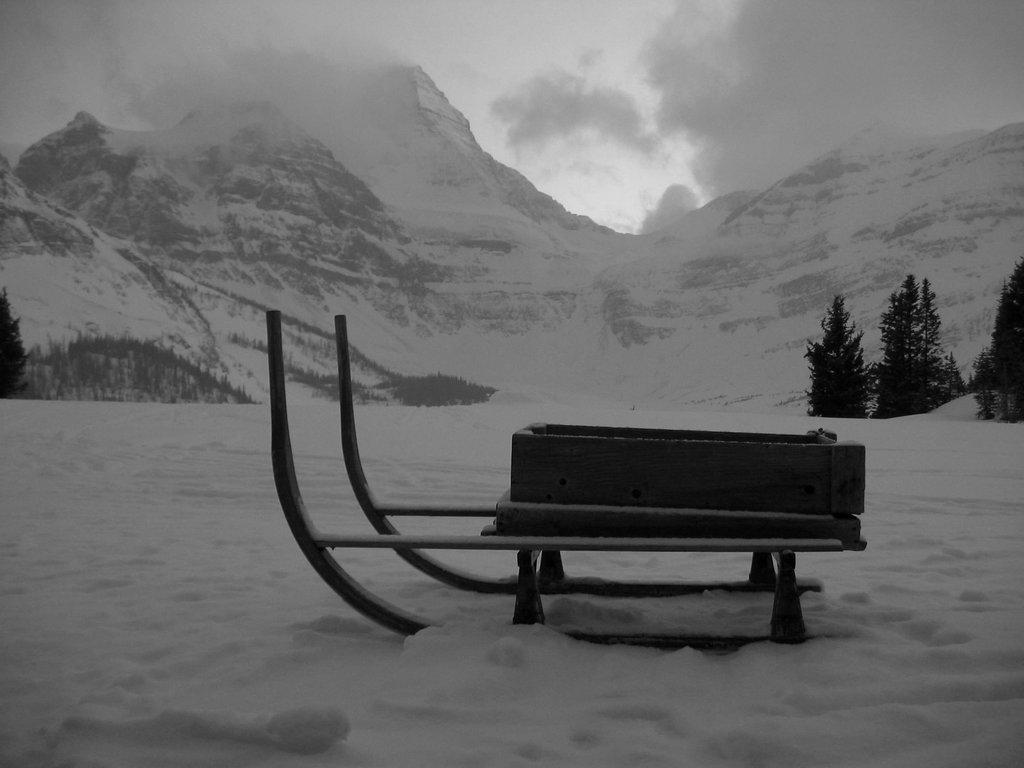Describe this image in one or two sentences. In this picture we can observe a sledge on the snow. There are some trees. In the background we can observe mountains and a sky with some clouds. This is a black and white image. 